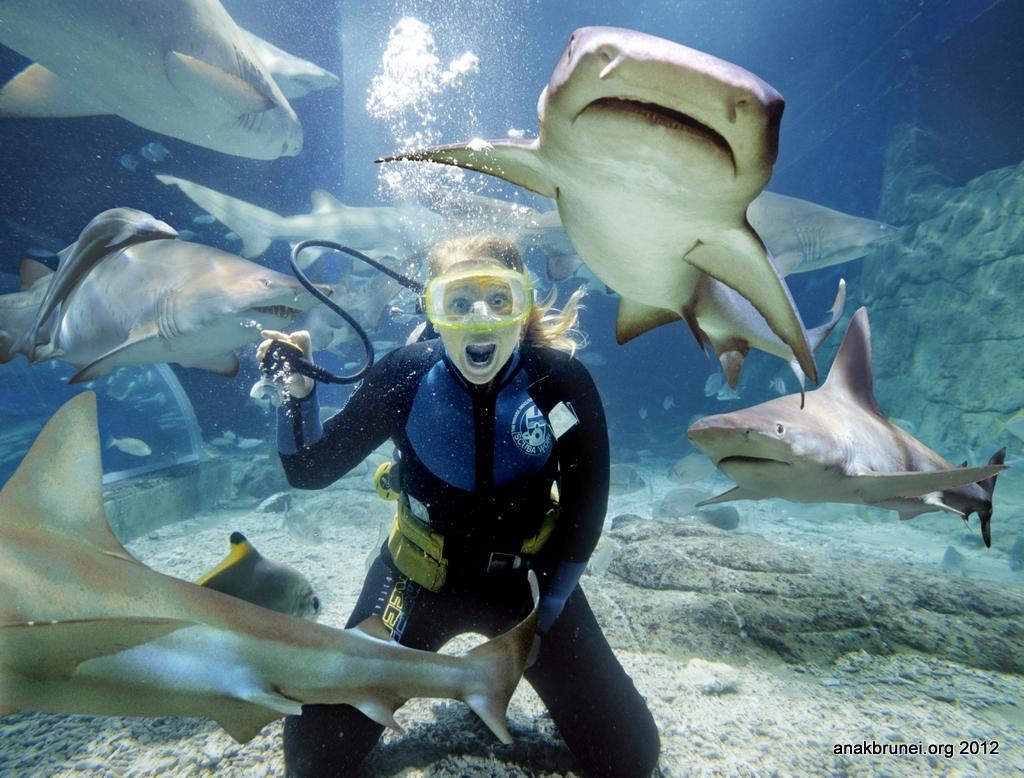How would you summarize this image in a sentence or two? In this image we can see a woman is under water and sharks are present around her. She is wearing black color swimming suit. 